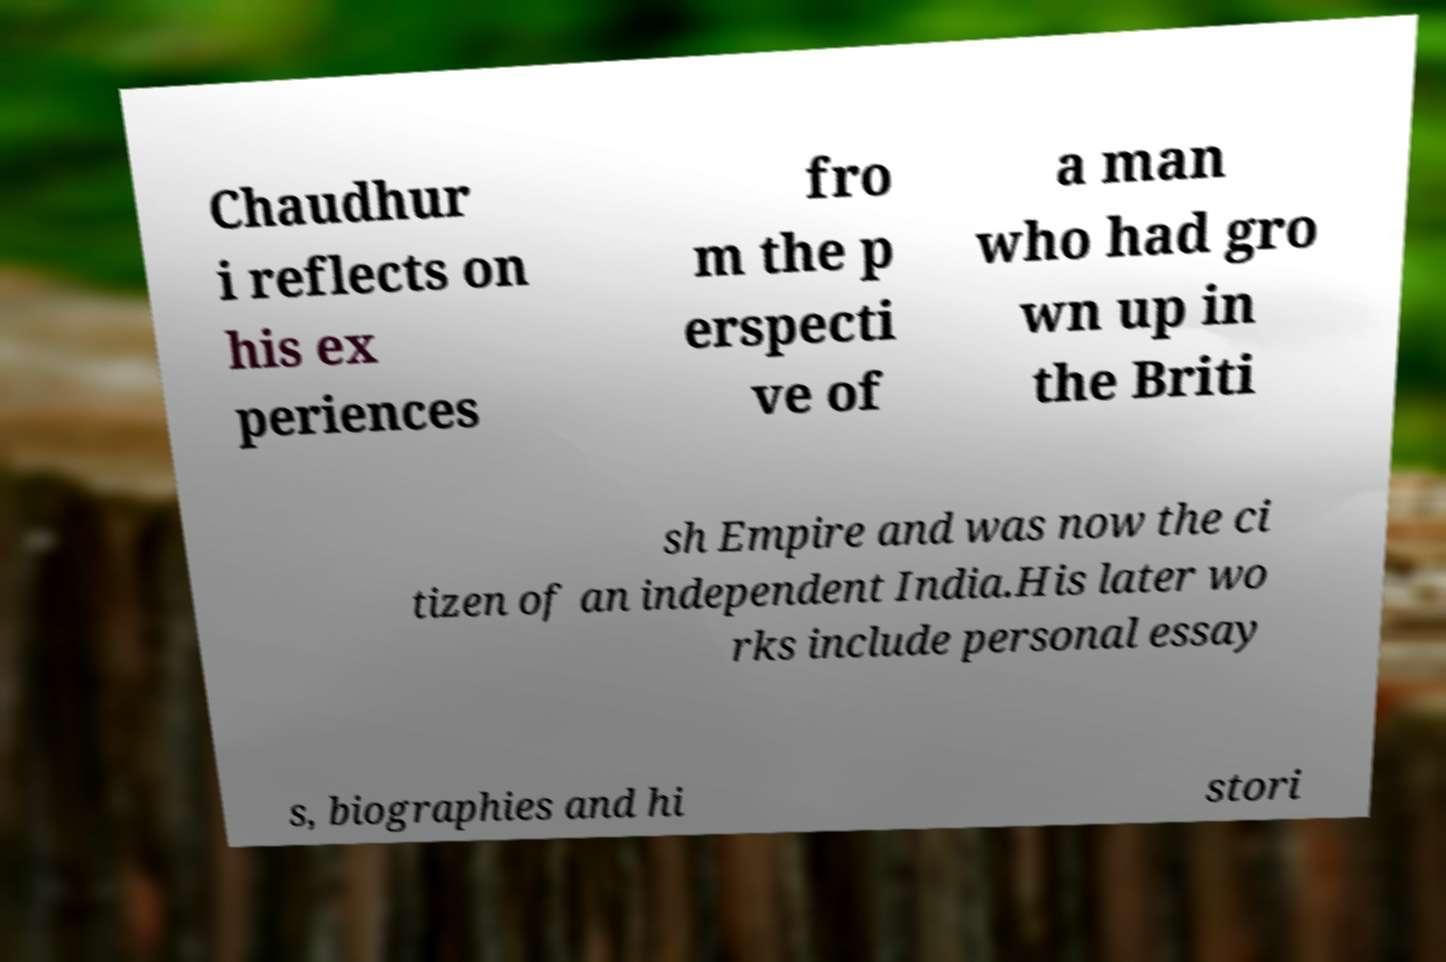For documentation purposes, I need the text within this image transcribed. Could you provide that? Chaudhur i reflects on his ex periences fro m the p erspecti ve of a man who had gro wn up in the Briti sh Empire and was now the ci tizen of an independent India.His later wo rks include personal essay s, biographies and hi stori 